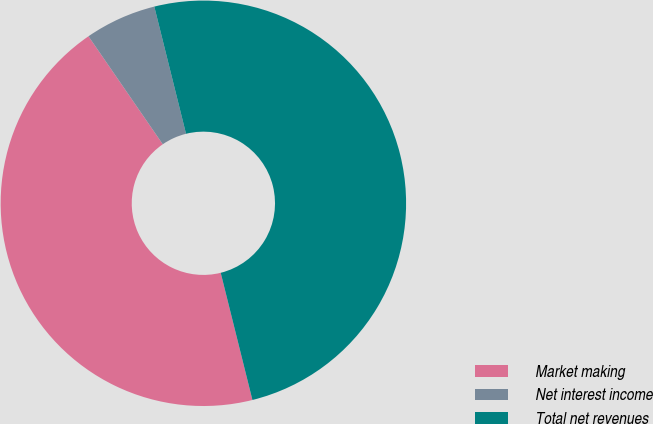Convert chart. <chart><loc_0><loc_0><loc_500><loc_500><pie_chart><fcel>Market making<fcel>Net interest income<fcel>Total net revenues<nl><fcel>44.3%<fcel>5.7%<fcel>50.0%<nl></chart> 